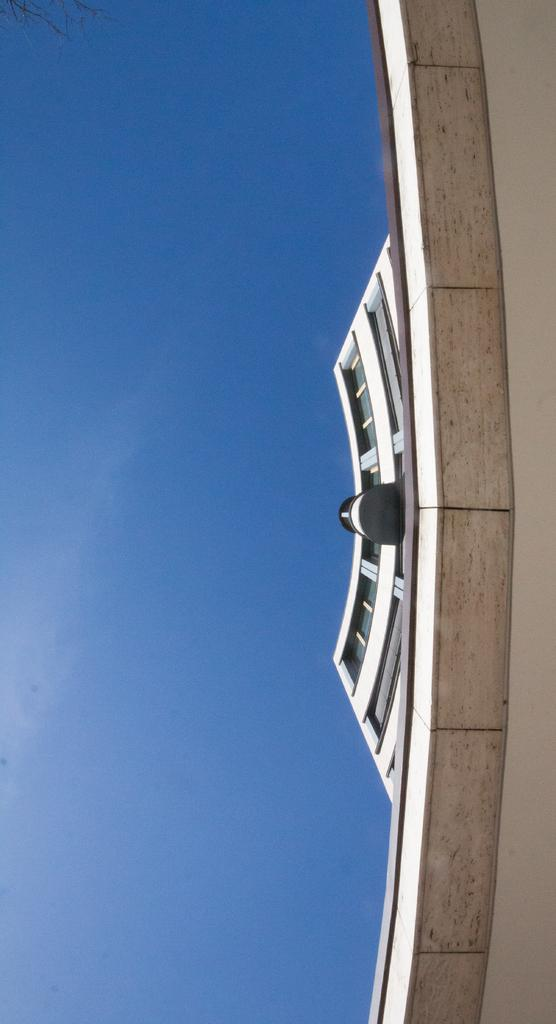What structure is located on the right side of the image? There is a building on the right side of the image. What type of rail is the minister using to travel to the building in the image? There is no minister or rail present in the image; it only features a building. What direction is the wind blowing in the image? There is no indication of wind or its direction in the image, as it only features a building. 